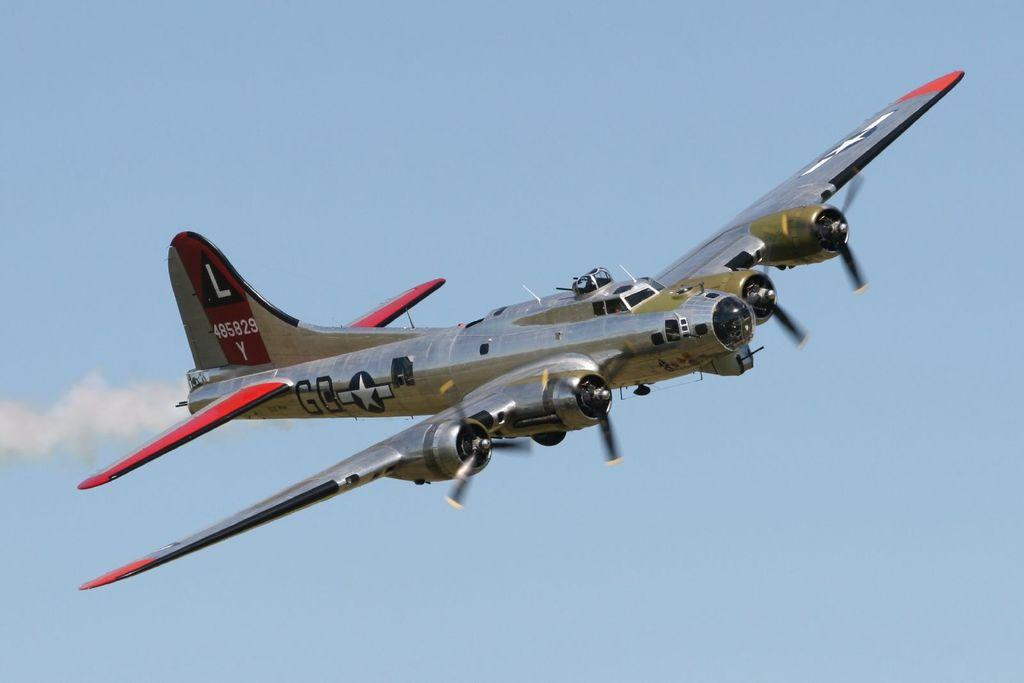<image>
Summarize the visual content of the image. A silver military plane with a large L on the tail flying in the sky. 